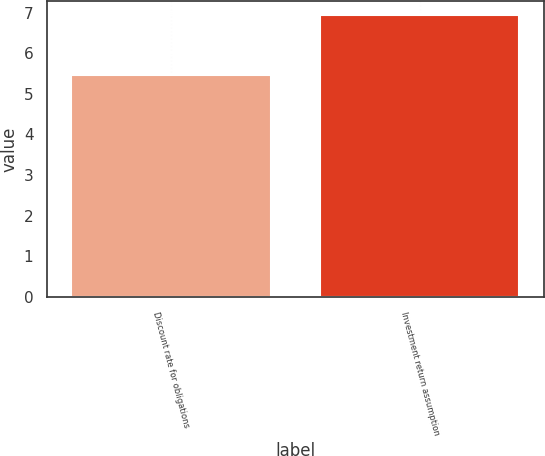Convert chart. <chart><loc_0><loc_0><loc_500><loc_500><bar_chart><fcel>Discount rate for obligations<fcel>Investment return assumption<nl><fcel>5.46<fcel>6.94<nl></chart> 